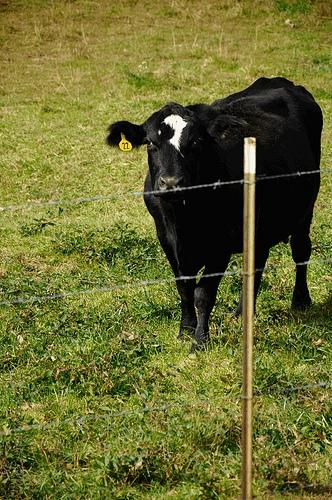Question: where is the picture taken?
Choices:
A. Rusia.
B. Ukraine.
C. Italy.
D. Near a cow, in the grass.
Answer with the letter. Answer: D Question: how many cows are there?
Choices:
A. 2.
B. 3.
C. 4.
D. 1.
Answer with the letter. Answer: D Question: what is the color of the grass?
Choices:
A. Brown.
B. Tan.
C. Green.
D. Red.
Answer with the letter. Answer: C Question: what is the animal seen?
Choices:
A. Horse.
B. Buffalo.
C. Chicken.
D. Cow.
Answer with the letter. Answer: D 